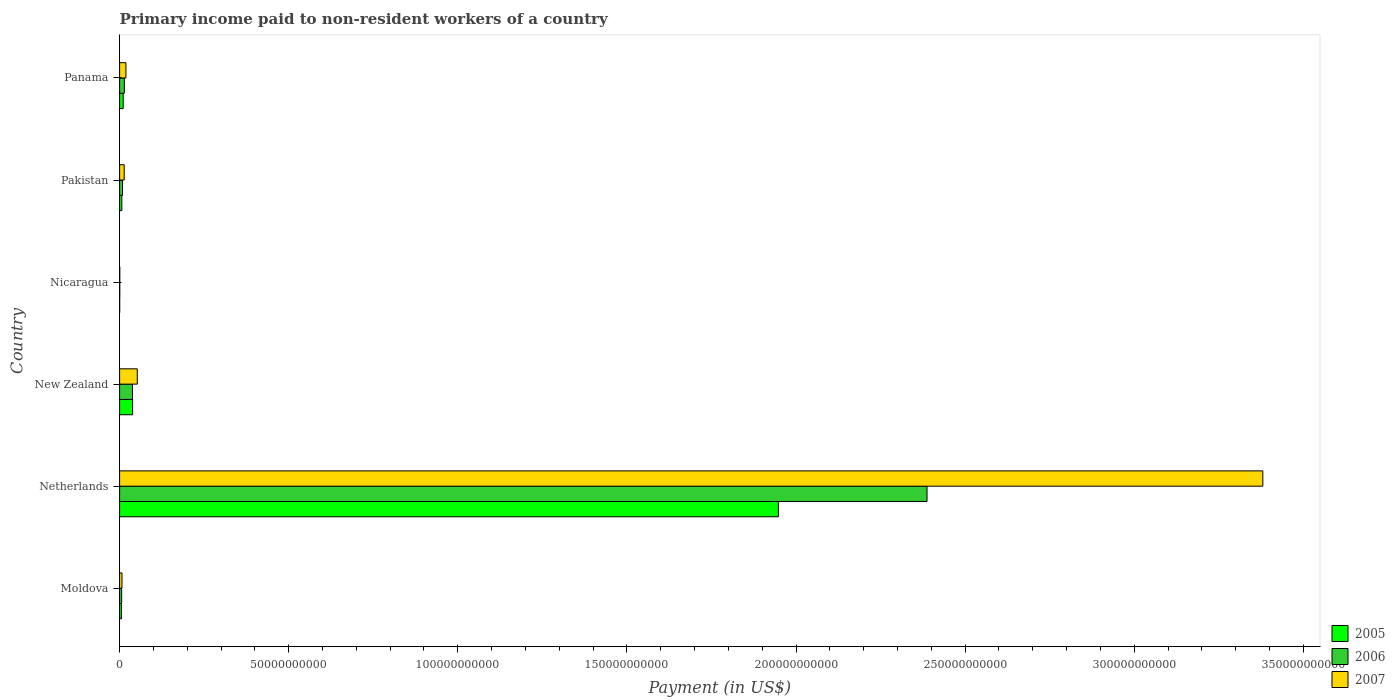How many different coloured bars are there?
Your response must be concise. 3. How many groups of bars are there?
Offer a very short reply. 6. Are the number of bars per tick equal to the number of legend labels?
Provide a short and direct response. Yes. How many bars are there on the 5th tick from the bottom?
Your answer should be compact. 3. What is the label of the 3rd group of bars from the top?
Your answer should be very brief. Nicaragua. What is the amount paid to workers in 2007 in Nicaragua?
Ensure brevity in your answer.  4.96e+07. Across all countries, what is the maximum amount paid to workers in 2005?
Your answer should be compact. 1.95e+11. Across all countries, what is the minimum amount paid to workers in 2006?
Give a very brief answer. 4.26e+07. In which country was the amount paid to workers in 2006 maximum?
Your response must be concise. Netherlands. In which country was the amount paid to workers in 2007 minimum?
Ensure brevity in your answer.  Nicaragua. What is the total amount paid to workers in 2005 in the graph?
Your answer should be very brief. 2.01e+11. What is the difference between the amount paid to workers in 2005 in Netherlands and that in New Zealand?
Your answer should be very brief. 1.91e+11. What is the difference between the amount paid to workers in 2005 in Panama and the amount paid to workers in 2006 in Pakistan?
Ensure brevity in your answer.  1.91e+08. What is the average amount paid to workers in 2006 per country?
Your answer should be compact. 4.09e+1. What is the difference between the amount paid to workers in 2005 and amount paid to workers in 2006 in Moldova?
Give a very brief answer. -6.66e+07. In how many countries, is the amount paid to workers in 2005 greater than 200000000000 US$?
Offer a very short reply. 0. What is the ratio of the amount paid to workers in 2007 in Nicaragua to that in Panama?
Provide a short and direct response. 0.03. Is the amount paid to workers in 2006 in Netherlands less than that in New Zealand?
Your answer should be compact. No. Is the difference between the amount paid to workers in 2005 in Pakistan and Panama greater than the difference between the amount paid to workers in 2006 in Pakistan and Panama?
Make the answer very short. Yes. What is the difference between the highest and the second highest amount paid to workers in 2005?
Provide a short and direct response. 1.91e+11. What is the difference between the highest and the lowest amount paid to workers in 2005?
Offer a terse response. 1.95e+11. In how many countries, is the amount paid to workers in 2007 greater than the average amount paid to workers in 2007 taken over all countries?
Your answer should be compact. 1. Is the sum of the amount paid to workers in 2005 in Netherlands and Nicaragua greater than the maximum amount paid to workers in 2007 across all countries?
Offer a very short reply. No. Are all the bars in the graph horizontal?
Your answer should be very brief. Yes. How many countries are there in the graph?
Offer a very short reply. 6. What is the difference between two consecutive major ticks on the X-axis?
Make the answer very short. 5.00e+1. Does the graph contain grids?
Your answer should be very brief. No. How many legend labels are there?
Give a very brief answer. 3. What is the title of the graph?
Ensure brevity in your answer.  Primary income paid to non-resident workers of a country. What is the label or title of the X-axis?
Your answer should be very brief. Payment (in US$). What is the label or title of the Y-axis?
Your answer should be very brief. Country. What is the Payment (in US$) in 2005 in Moldova?
Keep it short and to the point. 5.39e+08. What is the Payment (in US$) in 2006 in Moldova?
Your answer should be compact. 6.06e+08. What is the Payment (in US$) in 2007 in Moldova?
Offer a very short reply. 7.10e+08. What is the Payment (in US$) of 2005 in Netherlands?
Keep it short and to the point. 1.95e+11. What is the Payment (in US$) in 2006 in Netherlands?
Your answer should be compact. 2.39e+11. What is the Payment (in US$) in 2007 in Netherlands?
Keep it short and to the point. 3.38e+11. What is the Payment (in US$) of 2005 in New Zealand?
Give a very brief answer. 3.85e+09. What is the Payment (in US$) of 2006 in New Zealand?
Offer a very short reply. 3.80e+09. What is the Payment (in US$) of 2007 in New Zealand?
Your response must be concise. 5.23e+09. What is the Payment (in US$) in 2005 in Nicaragua?
Your answer should be very brief. 2.27e+07. What is the Payment (in US$) in 2006 in Nicaragua?
Provide a short and direct response. 4.26e+07. What is the Payment (in US$) of 2007 in Nicaragua?
Provide a succinct answer. 4.96e+07. What is the Payment (in US$) in 2005 in Pakistan?
Your response must be concise. 6.57e+08. What is the Payment (in US$) of 2006 in Pakistan?
Give a very brief answer. 8.64e+08. What is the Payment (in US$) of 2007 in Pakistan?
Your answer should be very brief. 1.36e+09. What is the Payment (in US$) in 2005 in Panama?
Your response must be concise. 1.05e+09. What is the Payment (in US$) in 2006 in Panama?
Offer a very short reply. 1.40e+09. What is the Payment (in US$) in 2007 in Panama?
Provide a succinct answer. 1.86e+09. Across all countries, what is the maximum Payment (in US$) in 2005?
Make the answer very short. 1.95e+11. Across all countries, what is the maximum Payment (in US$) of 2006?
Provide a succinct answer. 2.39e+11. Across all countries, what is the maximum Payment (in US$) in 2007?
Ensure brevity in your answer.  3.38e+11. Across all countries, what is the minimum Payment (in US$) in 2005?
Your response must be concise. 2.27e+07. Across all countries, what is the minimum Payment (in US$) in 2006?
Make the answer very short. 4.26e+07. Across all countries, what is the minimum Payment (in US$) of 2007?
Provide a short and direct response. 4.96e+07. What is the total Payment (in US$) of 2005 in the graph?
Ensure brevity in your answer.  2.01e+11. What is the total Payment (in US$) of 2006 in the graph?
Provide a succinct answer. 2.45e+11. What is the total Payment (in US$) of 2007 in the graph?
Make the answer very short. 3.47e+11. What is the difference between the Payment (in US$) of 2005 in Moldova and that in Netherlands?
Your response must be concise. -1.94e+11. What is the difference between the Payment (in US$) of 2006 in Moldova and that in Netherlands?
Provide a succinct answer. -2.38e+11. What is the difference between the Payment (in US$) of 2007 in Moldova and that in Netherlands?
Ensure brevity in your answer.  -3.37e+11. What is the difference between the Payment (in US$) of 2005 in Moldova and that in New Zealand?
Your answer should be compact. -3.31e+09. What is the difference between the Payment (in US$) in 2006 in Moldova and that in New Zealand?
Your answer should be compact. -3.20e+09. What is the difference between the Payment (in US$) in 2007 in Moldova and that in New Zealand?
Your answer should be compact. -4.52e+09. What is the difference between the Payment (in US$) in 2005 in Moldova and that in Nicaragua?
Make the answer very short. 5.17e+08. What is the difference between the Payment (in US$) of 2006 in Moldova and that in Nicaragua?
Ensure brevity in your answer.  5.63e+08. What is the difference between the Payment (in US$) in 2007 in Moldova and that in Nicaragua?
Give a very brief answer. 6.60e+08. What is the difference between the Payment (in US$) in 2005 in Moldova and that in Pakistan?
Offer a terse response. -1.18e+08. What is the difference between the Payment (in US$) in 2006 in Moldova and that in Pakistan?
Give a very brief answer. -2.58e+08. What is the difference between the Payment (in US$) in 2007 in Moldova and that in Pakistan?
Your answer should be compact. -6.47e+08. What is the difference between the Payment (in US$) in 2005 in Moldova and that in Panama?
Your answer should be compact. -5.16e+08. What is the difference between the Payment (in US$) in 2006 in Moldova and that in Panama?
Offer a terse response. -7.97e+08. What is the difference between the Payment (in US$) in 2007 in Moldova and that in Panama?
Offer a very short reply. -1.15e+09. What is the difference between the Payment (in US$) in 2005 in Netherlands and that in New Zealand?
Offer a very short reply. 1.91e+11. What is the difference between the Payment (in US$) in 2006 in Netherlands and that in New Zealand?
Keep it short and to the point. 2.35e+11. What is the difference between the Payment (in US$) of 2007 in Netherlands and that in New Zealand?
Offer a terse response. 3.33e+11. What is the difference between the Payment (in US$) of 2005 in Netherlands and that in Nicaragua?
Your answer should be compact. 1.95e+11. What is the difference between the Payment (in US$) in 2006 in Netherlands and that in Nicaragua?
Make the answer very short. 2.39e+11. What is the difference between the Payment (in US$) in 2007 in Netherlands and that in Nicaragua?
Offer a very short reply. 3.38e+11. What is the difference between the Payment (in US$) of 2005 in Netherlands and that in Pakistan?
Provide a succinct answer. 1.94e+11. What is the difference between the Payment (in US$) in 2006 in Netherlands and that in Pakistan?
Ensure brevity in your answer.  2.38e+11. What is the difference between the Payment (in US$) of 2007 in Netherlands and that in Pakistan?
Your answer should be very brief. 3.37e+11. What is the difference between the Payment (in US$) of 2005 in Netherlands and that in Panama?
Your response must be concise. 1.94e+11. What is the difference between the Payment (in US$) in 2006 in Netherlands and that in Panama?
Your response must be concise. 2.37e+11. What is the difference between the Payment (in US$) of 2007 in Netherlands and that in Panama?
Keep it short and to the point. 3.36e+11. What is the difference between the Payment (in US$) of 2005 in New Zealand and that in Nicaragua?
Your answer should be very brief. 3.82e+09. What is the difference between the Payment (in US$) in 2006 in New Zealand and that in Nicaragua?
Your answer should be very brief. 3.76e+09. What is the difference between the Payment (in US$) in 2007 in New Zealand and that in Nicaragua?
Offer a terse response. 5.18e+09. What is the difference between the Payment (in US$) of 2005 in New Zealand and that in Pakistan?
Ensure brevity in your answer.  3.19e+09. What is the difference between the Payment (in US$) of 2006 in New Zealand and that in Pakistan?
Keep it short and to the point. 2.94e+09. What is the difference between the Payment (in US$) in 2007 in New Zealand and that in Pakistan?
Provide a short and direct response. 3.87e+09. What is the difference between the Payment (in US$) in 2005 in New Zealand and that in Panama?
Offer a terse response. 2.79e+09. What is the difference between the Payment (in US$) in 2006 in New Zealand and that in Panama?
Keep it short and to the point. 2.40e+09. What is the difference between the Payment (in US$) in 2007 in New Zealand and that in Panama?
Your answer should be compact. 3.36e+09. What is the difference between the Payment (in US$) of 2005 in Nicaragua and that in Pakistan?
Provide a short and direct response. -6.34e+08. What is the difference between the Payment (in US$) of 2006 in Nicaragua and that in Pakistan?
Provide a short and direct response. -8.21e+08. What is the difference between the Payment (in US$) in 2007 in Nicaragua and that in Pakistan?
Make the answer very short. -1.31e+09. What is the difference between the Payment (in US$) of 2005 in Nicaragua and that in Panama?
Keep it short and to the point. -1.03e+09. What is the difference between the Payment (in US$) in 2006 in Nicaragua and that in Panama?
Your response must be concise. -1.36e+09. What is the difference between the Payment (in US$) of 2007 in Nicaragua and that in Panama?
Give a very brief answer. -1.81e+09. What is the difference between the Payment (in US$) of 2005 in Pakistan and that in Panama?
Your answer should be compact. -3.98e+08. What is the difference between the Payment (in US$) in 2006 in Pakistan and that in Panama?
Offer a very short reply. -5.39e+08. What is the difference between the Payment (in US$) of 2007 in Pakistan and that in Panama?
Keep it short and to the point. -5.07e+08. What is the difference between the Payment (in US$) in 2005 in Moldova and the Payment (in US$) in 2006 in Netherlands?
Your answer should be very brief. -2.38e+11. What is the difference between the Payment (in US$) in 2005 in Moldova and the Payment (in US$) in 2007 in Netherlands?
Provide a short and direct response. -3.37e+11. What is the difference between the Payment (in US$) of 2006 in Moldova and the Payment (in US$) of 2007 in Netherlands?
Keep it short and to the point. -3.37e+11. What is the difference between the Payment (in US$) in 2005 in Moldova and the Payment (in US$) in 2006 in New Zealand?
Provide a succinct answer. -3.27e+09. What is the difference between the Payment (in US$) of 2005 in Moldova and the Payment (in US$) of 2007 in New Zealand?
Provide a short and direct response. -4.69e+09. What is the difference between the Payment (in US$) of 2006 in Moldova and the Payment (in US$) of 2007 in New Zealand?
Offer a very short reply. -4.62e+09. What is the difference between the Payment (in US$) in 2005 in Moldova and the Payment (in US$) in 2006 in Nicaragua?
Your answer should be very brief. 4.97e+08. What is the difference between the Payment (in US$) of 2005 in Moldova and the Payment (in US$) of 2007 in Nicaragua?
Give a very brief answer. 4.90e+08. What is the difference between the Payment (in US$) in 2006 in Moldova and the Payment (in US$) in 2007 in Nicaragua?
Make the answer very short. 5.56e+08. What is the difference between the Payment (in US$) in 2005 in Moldova and the Payment (in US$) in 2006 in Pakistan?
Make the answer very short. -3.25e+08. What is the difference between the Payment (in US$) in 2005 in Moldova and the Payment (in US$) in 2007 in Pakistan?
Ensure brevity in your answer.  -8.18e+08. What is the difference between the Payment (in US$) of 2006 in Moldova and the Payment (in US$) of 2007 in Pakistan?
Ensure brevity in your answer.  -7.51e+08. What is the difference between the Payment (in US$) in 2005 in Moldova and the Payment (in US$) in 2006 in Panama?
Offer a terse response. -8.64e+08. What is the difference between the Payment (in US$) in 2005 in Moldova and the Payment (in US$) in 2007 in Panama?
Make the answer very short. -1.32e+09. What is the difference between the Payment (in US$) in 2006 in Moldova and the Payment (in US$) in 2007 in Panama?
Provide a succinct answer. -1.26e+09. What is the difference between the Payment (in US$) in 2005 in Netherlands and the Payment (in US$) in 2006 in New Zealand?
Offer a terse response. 1.91e+11. What is the difference between the Payment (in US$) in 2005 in Netherlands and the Payment (in US$) in 2007 in New Zealand?
Your answer should be very brief. 1.90e+11. What is the difference between the Payment (in US$) in 2006 in Netherlands and the Payment (in US$) in 2007 in New Zealand?
Your answer should be compact. 2.34e+11. What is the difference between the Payment (in US$) in 2005 in Netherlands and the Payment (in US$) in 2006 in Nicaragua?
Your answer should be compact. 1.95e+11. What is the difference between the Payment (in US$) in 2005 in Netherlands and the Payment (in US$) in 2007 in Nicaragua?
Offer a terse response. 1.95e+11. What is the difference between the Payment (in US$) of 2006 in Netherlands and the Payment (in US$) of 2007 in Nicaragua?
Keep it short and to the point. 2.39e+11. What is the difference between the Payment (in US$) in 2005 in Netherlands and the Payment (in US$) in 2006 in Pakistan?
Keep it short and to the point. 1.94e+11. What is the difference between the Payment (in US$) in 2005 in Netherlands and the Payment (in US$) in 2007 in Pakistan?
Provide a succinct answer. 1.93e+11. What is the difference between the Payment (in US$) of 2006 in Netherlands and the Payment (in US$) of 2007 in Pakistan?
Give a very brief answer. 2.37e+11. What is the difference between the Payment (in US$) of 2005 in Netherlands and the Payment (in US$) of 2006 in Panama?
Provide a succinct answer. 1.93e+11. What is the difference between the Payment (in US$) in 2005 in Netherlands and the Payment (in US$) in 2007 in Panama?
Provide a succinct answer. 1.93e+11. What is the difference between the Payment (in US$) of 2006 in Netherlands and the Payment (in US$) of 2007 in Panama?
Make the answer very short. 2.37e+11. What is the difference between the Payment (in US$) in 2005 in New Zealand and the Payment (in US$) in 2006 in Nicaragua?
Make the answer very short. 3.80e+09. What is the difference between the Payment (in US$) in 2005 in New Zealand and the Payment (in US$) in 2007 in Nicaragua?
Keep it short and to the point. 3.80e+09. What is the difference between the Payment (in US$) of 2006 in New Zealand and the Payment (in US$) of 2007 in Nicaragua?
Your response must be concise. 3.76e+09. What is the difference between the Payment (in US$) in 2005 in New Zealand and the Payment (in US$) in 2006 in Pakistan?
Keep it short and to the point. 2.98e+09. What is the difference between the Payment (in US$) of 2005 in New Zealand and the Payment (in US$) of 2007 in Pakistan?
Your answer should be very brief. 2.49e+09. What is the difference between the Payment (in US$) in 2006 in New Zealand and the Payment (in US$) in 2007 in Pakistan?
Your response must be concise. 2.45e+09. What is the difference between the Payment (in US$) in 2005 in New Zealand and the Payment (in US$) in 2006 in Panama?
Provide a succinct answer. 2.44e+09. What is the difference between the Payment (in US$) of 2005 in New Zealand and the Payment (in US$) of 2007 in Panama?
Offer a terse response. 1.98e+09. What is the difference between the Payment (in US$) in 2006 in New Zealand and the Payment (in US$) in 2007 in Panama?
Offer a very short reply. 1.94e+09. What is the difference between the Payment (in US$) in 2005 in Nicaragua and the Payment (in US$) in 2006 in Pakistan?
Your answer should be very brief. -8.41e+08. What is the difference between the Payment (in US$) in 2005 in Nicaragua and the Payment (in US$) in 2007 in Pakistan?
Offer a very short reply. -1.33e+09. What is the difference between the Payment (in US$) of 2006 in Nicaragua and the Payment (in US$) of 2007 in Pakistan?
Offer a very short reply. -1.31e+09. What is the difference between the Payment (in US$) of 2005 in Nicaragua and the Payment (in US$) of 2006 in Panama?
Ensure brevity in your answer.  -1.38e+09. What is the difference between the Payment (in US$) in 2005 in Nicaragua and the Payment (in US$) in 2007 in Panama?
Offer a terse response. -1.84e+09. What is the difference between the Payment (in US$) in 2006 in Nicaragua and the Payment (in US$) in 2007 in Panama?
Keep it short and to the point. -1.82e+09. What is the difference between the Payment (in US$) in 2005 in Pakistan and the Payment (in US$) in 2006 in Panama?
Make the answer very short. -7.46e+08. What is the difference between the Payment (in US$) in 2005 in Pakistan and the Payment (in US$) in 2007 in Panama?
Make the answer very short. -1.21e+09. What is the difference between the Payment (in US$) of 2006 in Pakistan and the Payment (in US$) of 2007 in Panama?
Your response must be concise. -1.00e+09. What is the average Payment (in US$) in 2005 per country?
Give a very brief answer. 3.35e+1. What is the average Payment (in US$) of 2006 per country?
Provide a short and direct response. 4.09e+1. What is the average Payment (in US$) in 2007 per country?
Your answer should be very brief. 5.79e+1. What is the difference between the Payment (in US$) in 2005 and Payment (in US$) in 2006 in Moldova?
Your answer should be very brief. -6.66e+07. What is the difference between the Payment (in US$) in 2005 and Payment (in US$) in 2007 in Moldova?
Offer a terse response. -1.71e+08. What is the difference between the Payment (in US$) in 2006 and Payment (in US$) in 2007 in Moldova?
Make the answer very short. -1.04e+08. What is the difference between the Payment (in US$) of 2005 and Payment (in US$) of 2006 in Netherlands?
Offer a terse response. -4.40e+1. What is the difference between the Payment (in US$) of 2005 and Payment (in US$) of 2007 in Netherlands?
Make the answer very short. -1.43e+11. What is the difference between the Payment (in US$) of 2006 and Payment (in US$) of 2007 in Netherlands?
Offer a very short reply. -9.93e+1. What is the difference between the Payment (in US$) in 2005 and Payment (in US$) in 2006 in New Zealand?
Your answer should be very brief. 4.28e+07. What is the difference between the Payment (in US$) of 2005 and Payment (in US$) of 2007 in New Zealand?
Offer a terse response. -1.38e+09. What is the difference between the Payment (in US$) of 2006 and Payment (in US$) of 2007 in New Zealand?
Give a very brief answer. -1.42e+09. What is the difference between the Payment (in US$) of 2005 and Payment (in US$) of 2006 in Nicaragua?
Keep it short and to the point. -1.99e+07. What is the difference between the Payment (in US$) of 2005 and Payment (in US$) of 2007 in Nicaragua?
Your answer should be compact. -2.69e+07. What is the difference between the Payment (in US$) of 2006 and Payment (in US$) of 2007 in Nicaragua?
Keep it short and to the point. -7.00e+06. What is the difference between the Payment (in US$) in 2005 and Payment (in US$) in 2006 in Pakistan?
Give a very brief answer. -2.07e+08. What is the difference between the Payment (in US$) in 2005 and Payment (in US$) in 2007 in Pakistan?
Ensure brevity in your answer.  -7.00e+08. What is the difference between the Payment (in US$) of 2006 and Payment (in US$) of 2007 in Pakistan?
Offer a terse response. -4.93e+08. What is the difference between the Payment (in US$) of 2005 and Payment (in US$) of 2006 in Panama?
Keep it short and to the point. -3.48e+08. What is the difference between the Payment (in US$) in 2005 and Payment (in US$) in 2007 in Panama?
Offer a terse response. -8.09e+08. What is the difference between the Payment (in US$) of 2006 and Payment (in US$) of 2007 in Panama?
Give a very brief answer. -4.61e+08. What is the ratio of the Payment (in US$) of 2005 in Moldova to that in Netherlands?
Ensure brevity in your answer.  0. What is the ratio of the Payment (in US$) of 2006 in Moldova to that in Netherlands?
Ensure brevity in your answer.  0. What is the ratio of the Payment (in US$) in 2007 in Moldova to that in Netherlands?
Your answer should be very brief. 0. What is the ratio of the Payment (in US$) in 2005 in Moldova to that in New Zealand?
Your answer should be very brief. 0.14. What is the ratio of the Payment (in US$) of 2006 in Moldova to that in New Zealand?
Make the answer very short. 0.16. What is the ratio of the Payment (in US$) of 2007 in Moldova to that in New Zealand?
Ensure brevity in your answer.  0.14. What is the ratio of the Payment (in US$) of 2005 in Moldova to that in Nicaragua?
Make the answer very short. 23.76. What is the ratio of the Payment (in US$) in 2006 in Moldova to that in Nicaragua?
Your response must be concise. 14.22. What is the ratio of the Payment (in US$) of 2007 in Moldova to that in Nicaragua?
Your answer should be compact. 14.32. What is the ratio of the Payment (in US$) in 2005 in Moldova to that in Pakistan?
Give a very brief answer. 0.82. What is the ratio of the Payment (in US$) of 2006 in Moldova to that in Pakistan?
Offer a terse response. 0.7. What is the ratio of the Payment (in US$) in 2007 in Moldova to that in Pakistan?
Provide a short and direct response. 0.52. What is the ratio of the Payment (in US$) in 2005 in Moldova to that in Panama?
Your answer should be very brief. 0.51. What is the ratio of the Payment (in US$) of 2006 in Moldova to that in Panama?
Offer a terse response. 0.43. What is the ratio of the Payment (in US$) of 2007 in Moldova to that in Panama?
Offer a very short reply. 0.38. What is the ratio of the Payment (in US$) in 2005 in Netherlands to that in New Zealand?
Provide a succinct answer. 50.63. What is the ratio of the Payment (in US$) of 2006 in Netherlands to that in New Zealand?
Keep it short and to the point. 62.75. What is the ratio of the Payment (in US$) of 2007 in Netherlands to that in New Zealand?
Offer a terse response. 64.67. What is the ratio of the Payment (in US$) of 2005 in Netherlands to that in Nicaragua?
Keep it short and to the point. 8581.15. What is the ratio of the Payment (in US$) of 2006 in Netherlands to that in Nicaragua?
Provide a short and direct response. 5604.32. What is the ratio of the Payment (in US$) in 2007 in Netherlands to that in Nicaragua?
Keep it short and to the point. 6815.22. What is the ratio of the Payment (in US$) of 2005 in Netherlands to that in Pakistan?
Your answer should be compact. 296.49. What is the ratio of the Payment (in US$) of 2006 in Netherlands to that in Pakistan?
Offer a terse response. 276.32. What is the ratio of the Payment (in US$) in 2007 in Netherlands to that in Pakistan?
Offer a very short reply. 249.1. What is the ratio of the Payment (in US$) of 2005 in Netherlands to that in Panama?
Provide a succinct answer. 184.67. What is the ratio of the Payment (in US$) in 2006 in Netherlands to that in Panama?
Give a very brief answer. 170.17. What is the ratio of the Payment (in US$) of 2007 in Netherlands to that in Panama?
Give a very brief answer. 181.33. What is the ratio of the Payment (in US$) in 2005 in New Zealand to that in Nicaragua?
Give a very brief answer. 169.49. What is the ratio of the Payment (in US$) of 2006 in New Zealand to that in Nicaragua?
Offer a terse response. 89.31. What is the ratio of the Payment (in US$) in 2007 in New Zealand to that in Nicaragua?
Give a very brief answer. 105.38. What is the ratio of the Payment (in US$) of 2005 in New Zealand to that in Pakistan?
Your response must be concise. 5.86. What is the ratio of the Payment (in US$) in 2006 in New Zealand to that in Pakistan?
Provide a short and direct response. 4.4. What is the ratio of the Payment (in US$) in 2007 in New Zealand to that in Pakistan?
Give a very brief answer. 3.85. What is the ratio of the Payment (in US$) in 2005 in New Zealand to that in Panama?
Your answer should be very brief. 3.65. What is the ratio of the Payment (in US$) of 2006 in New Zealand to that in Panama?
Provide a short and direct response. 2.71. What is the ratio of the Payment (in US$) of 2007 in New Zealand to that in Panama?
Make the answer very short. 2.8. What is the ratio of the Payment (in US$) of 2005 in Nicaragua to that in Pakistan?
Offer a terse response. 0.03. What is the ratio of the Payment (in US$) in 2006 in Nicaragua to that in Pakistan?
Offer a terse response. 0.05. What is the ratio of the Payment (in US$) in 2007 in Nicaragua to that in Pakistan?
Your answer should be compact. 0.04. What is the ratio of the Payment (in US$) of 2005 in Nicaragua to that in Panama?
Offer a very short reply. 0.02. What is the ratio of the Payment (in US$) of 2006 in Nicaragua to that in Panama?
Offer a very short reply. 0.03. What is the ratio of the Payment (in US$) in 2007 in Nicaragua to that in Panama?
Your answer should be compact. 0.03. What is the ratio of the Payment (in US$) in 2005 in Pakistan to that in Panama?
Offer a very short reply. 0.62. What is the ratio of the Payment (in US$) in 2006 in Pakistan to that in Panama?
Make the answer very short. 0.62. What is the ratio of the Payment (in US$) in 2007 in Pakistan to that in Panama?
Keep it short and to the point. 0.73. What is the difference between the highest and the second highest Payment (in US$) in 2005?
Ensure brevity in your answer.  1.91e+11. What is the difference between the highest and the second highest Payment (in US$) in 2006?
Ensure brevity in your answer.  2.35e+11. What is the difference between the highest and the second highest Payment (in US$) of 2007?
Your response must be concise. 3.33e+11. What is the difference between the highest and the lowest Payment (in US$) in 2005?
Offer a very short reply. 1.95e+11. What is the difference between the highest and the lowest Payment (in US$) in 2006?
Provide a short and direct response. 2.39e+11. What is the difference between the highest and the lowest Payment (in US$) of 2007?
Give a very brief answer. 3.38e+11. 